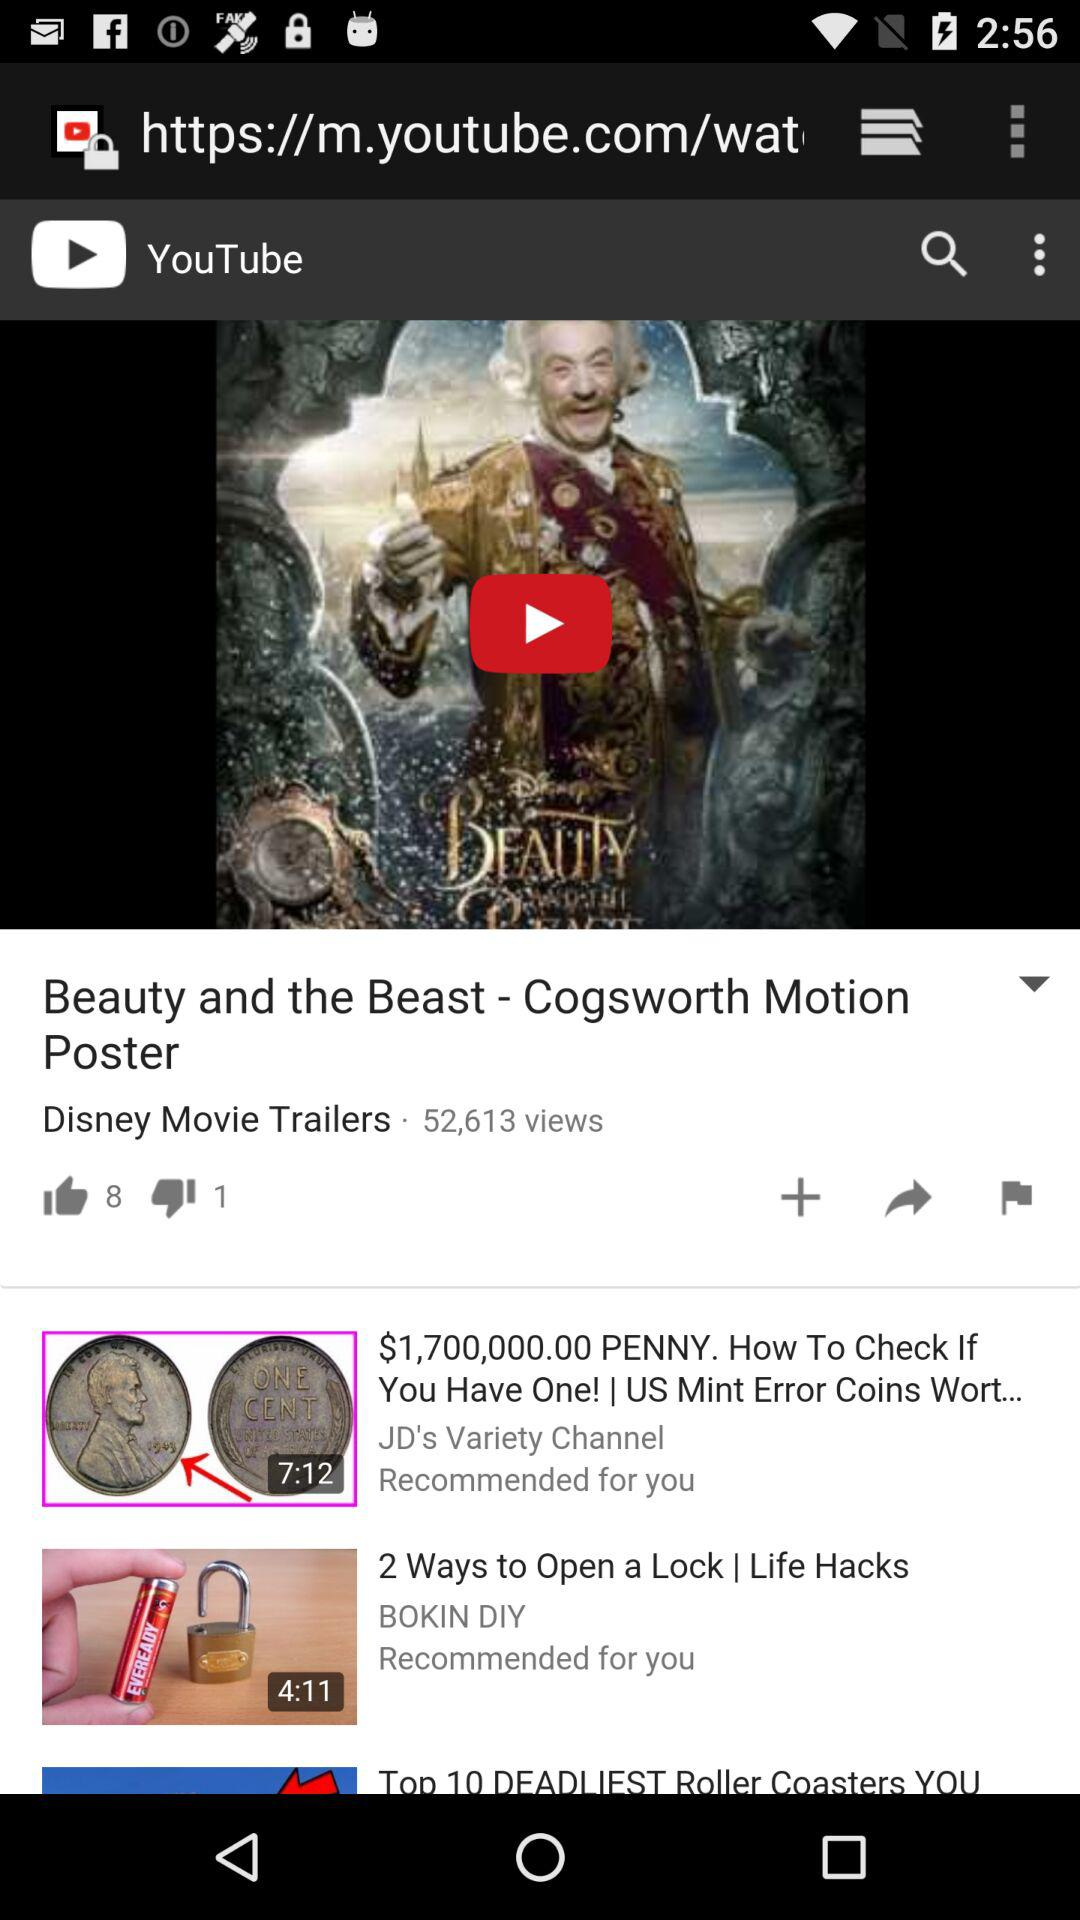What is the time duration of the video "2 Ways to Open a Lock"? The time duration of the video "2 Ways to Open a Lock" is 4 minutes 11 seconds. 